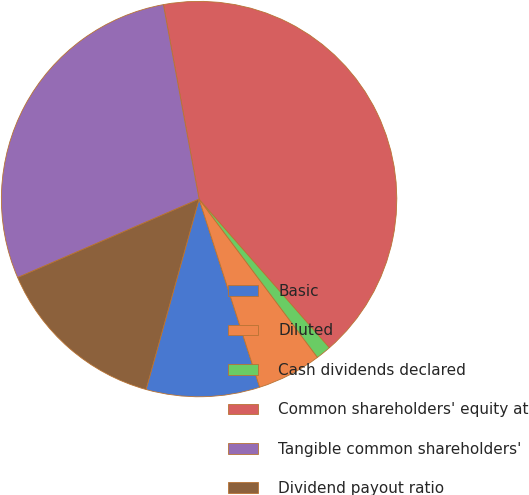<chart> <loc_0><loc_0><loc_500><loc_500><pie_chart><fcel>Basic<fcel>Diluted<fcel>Cash dividends declared<fcel>Common shareholders' equity at<fcel>Tangible common shareholders'<fcel>Dividend payout ratio<nl><fcel>9.28%<fcel>5.26%<fcel>1.24%<fcel>41.43%<fcel>28.61%<fcel>14.18%<nl></chart> 